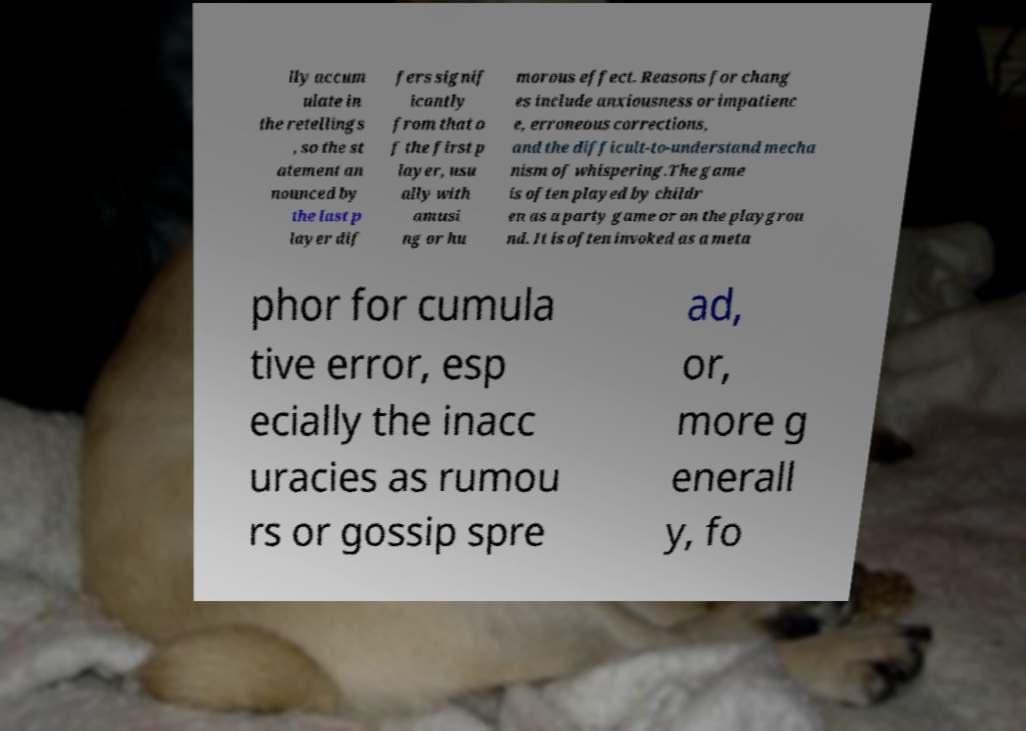I need the written content from this picture converted into text. Can you do that? lly accum ulate in the retellings , so the st atement an nounced by the last p layer dif fers signif icantly from that o f the first p layer, usu ally with amusi ng or hu morous effect. Reasons for chang es include anxiousness or impatienc e, erroneous corrections, and the difficult-to-understand mecha nism of whispering.The game is often played by childr en as a party game or on the playgrou nd. It is often invoked as a meta phor for cumula tive error, esp ecially the inacc uracies as rumou rs or gossip spre ad, or, more g enerall y, fo 